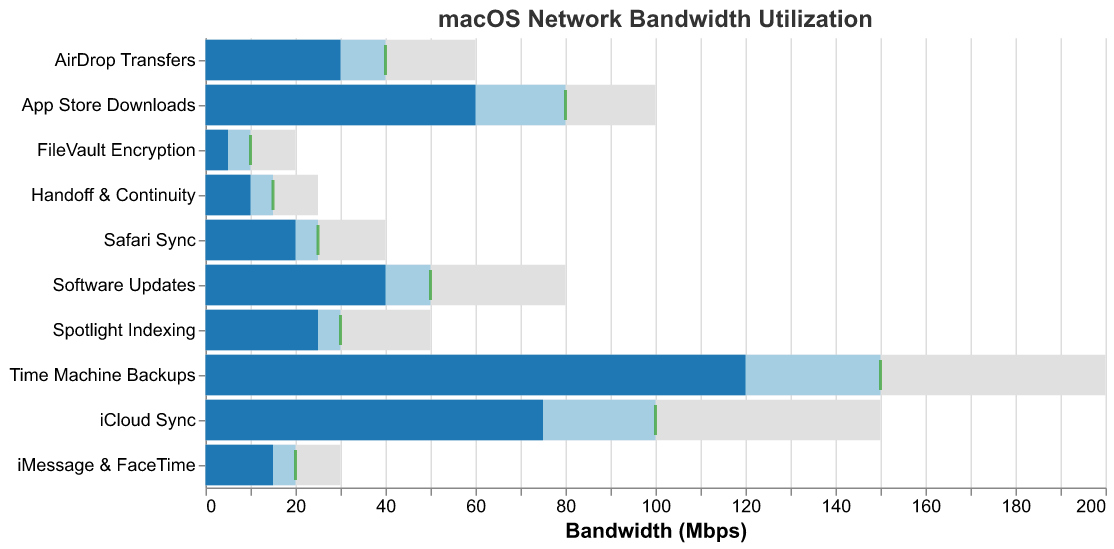How many services have actual bandwidth utilization above their target? To determine this, compare the actual utilization values with the target values for each service. Services where the actual value exceeds the target are: Time Machine Backups.
Answer: 1 What is the overall maximum bandwidth limit set across all services? Look at the 'Max' column for each service and identify the highest value. The max value is 200 for Time Machine Backups.
Answer: 200 Mbps Which service has the highest actual bandwidth utilization? Compare the 'Actual' bandwidth values for all services. Time Machine Backups has the highest actual utilization at 120 Mbps.
Answer: Time Machine Backups By how much does FileVault Encryption fall short of its target utilization? Subtract the actual utilization value of FileVault Encryption from its target value: 10 - 5 = 5.
Answer: 5 Mbps What is the average actual bandwidth utilization across all services? Sum the actual values: 75 + 120 + 40 + 25 + 15 + 60 + 30 + 10 + 5 + 20 = 400. Then divide by the number of services (10): 400 / 10 = 40.
Answer: 40 Mbps How many services have an actual bandwidth utilization less than 50 Mbps? Identify services with actual utilization under 50 Mbps: Software Updates, Spotlight Indexing, iMessage & FaceTime, AirDrop Transfers, Handoff & Continuity, FileVault Encryption, Safari Sync. Count them: 7.
Answer: 7 services Compare the target value of App Store Downloads to its actual value. Is it higher, lower, or equal? Look at both values for App Store Downloads; the actual value (60 Mbps) is lower than the target value (80 Mbps).
Answer: Lower Which service has the closest actual bandwidth utilization to its target without exceeding it? Compare the difference between actual and target values for each service; Spotlight Indexing is closest with an actual value of 25 and a target of 30.
Answer: Spotlight Indexing How much more bandwidth is used by iCloud Sync compared to Handoff & Continuity? Subtract the actual value of Handoff & Continuity from iCloud Sync: 75 - 10 = 65.
Answer: 65 Mbps Which service has the smallest difference between its max and actual bandwidth values? Calculate the difference between max and actual values for each service; FileVault Encryption has the smallest difference: 20 - 5 = 15.
Answer: FileVault Encryption 